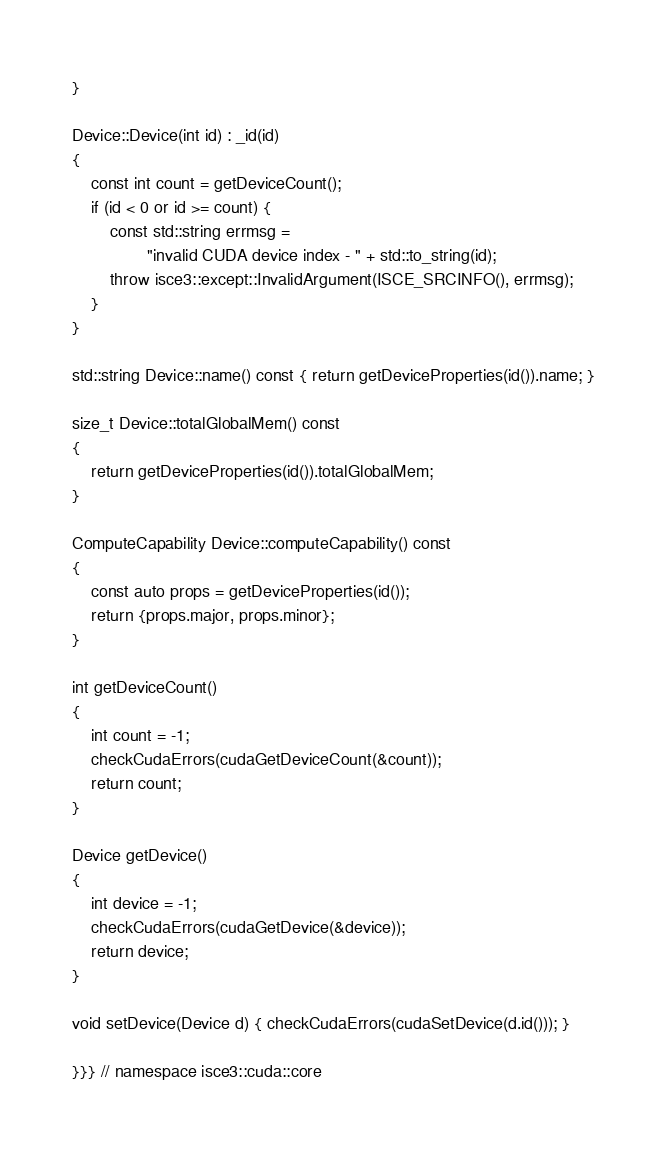Convert code to text. <code><loc_0><loc_0><loc_500><loc_500><_Cuda_>}

Device::Device(int id) : _id(id)
{
    const int count = getDeviceCount();
    if (id < 0 or id >= count) {
        const std::string errmsg =
                "invalid CUDA device index - " + std::to_string(id);
        throw isce3::except::InvalidArgument(ISCE_SRCINFO(), errmsg);
    }
}

std::string Device::name() const { return getDeviceProperties(id()).name; }

size_t Device::totalGlobalMem() const
{
    return getDeviceProperties(id()).totalGlobalMem;
}

ComputeCapability Device::computeCapability() const
{
    const auto props = getDeviceProperties(id());
    return {props.major, props.minor};
}

int getDeviceCount()
{
    int count = -1;
    checkCudaErrors(cudaGetDeviceCount(&count));
    return count;
}

Device getDevice()
{
    int device = -1;
    checkCudaErrors(cudaGetDevice(&device));
    return device;
}

void setDevice(Device d) { checkCudaErrors(cudaSetDevice(d.id())); }

}}} // namespace isce3::cuda::core
</code> 